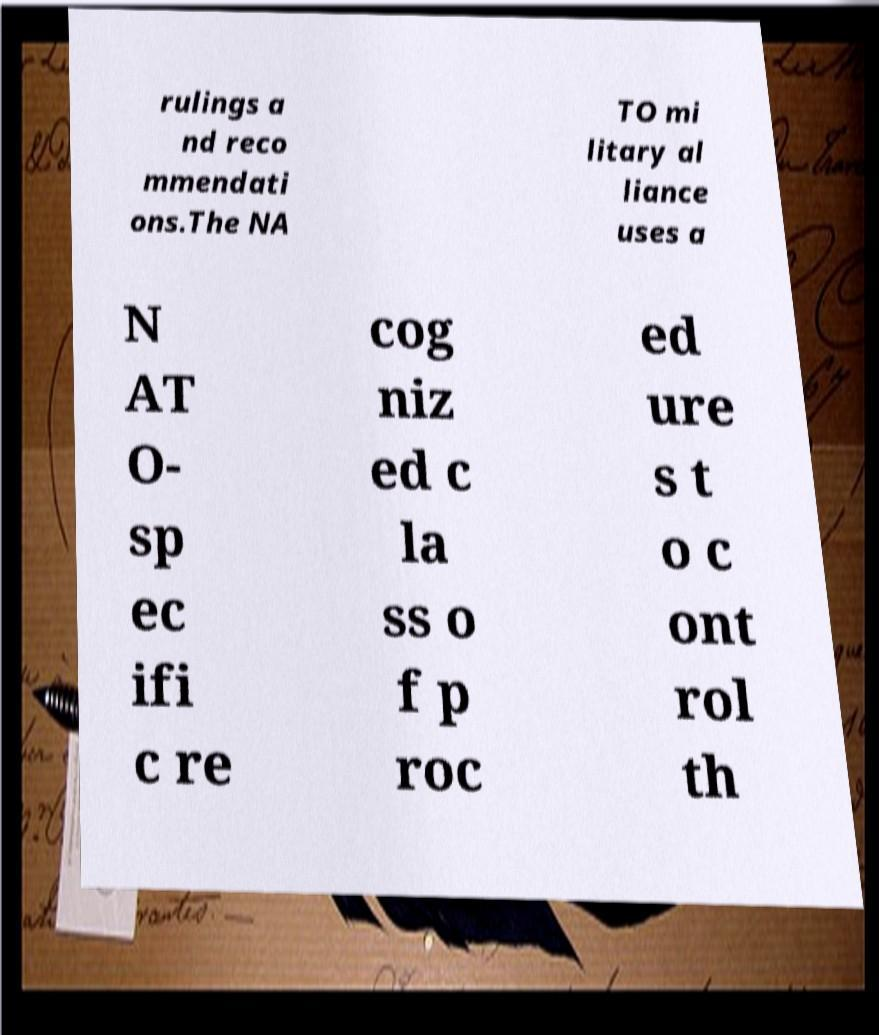There's text embedded in this image that I need extracted. Can you transcribe it verbatim? rulings a nd reco mmendati ons.The NA TO mi litary al liance uses a N AT O- sp ec ifi c re cog niz ed c la ss o f p roc ed ure s t o c ont rol th 